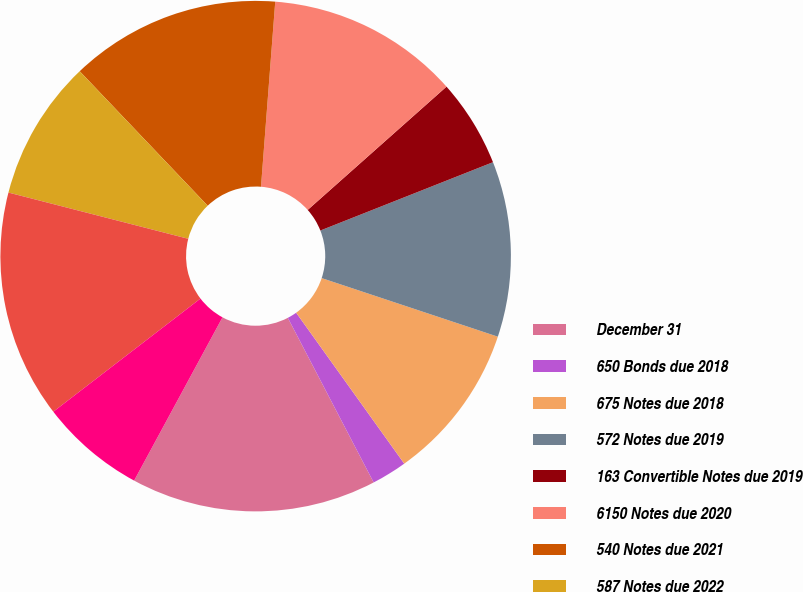Convert chart. <chart><loc_0><loc_0><loc_500><loc_500><pie_chart><fcel>December 31<fcel>650 Bonds due 2018<fcel>675 Notes due 2018<fcel>572 Notes due 2019<fcel>163 Convertible Notes due 2019<fcel>6150 Notes due 2020<fcel>540 Notes due 2021<fcel>587 Notes due 2022<fcel>5125 Notes due 2024<fcel>590 Notes due 2027<nl><fcel>15.55%<fcel>2.24%<fcel>10.0%<fcel>11.11%<fcel>5.56%<fcel>12.22%<fcel>13.33%<fcel>8.89%<fcel>14.44%<fcel>6.67%<nl></chart> 